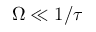Convert formula to latex. <formula><loc_0><loc_0><loc_500><loc_500>\Omega \ll 1 / \tau</formula> 